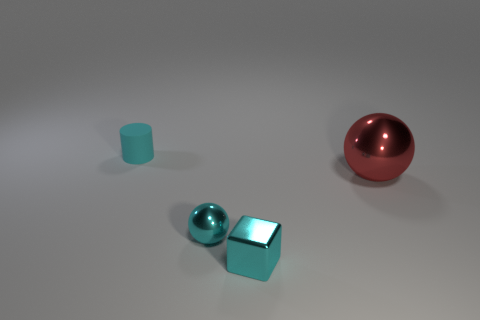What number of other objects are there of the same color as the tiny matte cylinder?
Ensure brevity in your answer.  2. The tiny thing that is both on the left side of the small cube and to the right of the rubber cylinder is what color?
Your answer should be very brief. Cyan. There is a metallic sphere on the right side of the cyan metallic object to the right of the sphere to the left of the red sphere; what size is it?
Your answer should be very brief. Large. How many objects are balls on the right side of the metallic block or tiny cyan objects that are in front of the small cyan matte cylinder?
Provide a short and direct response. 3. There is a red metallic thing; what shape is it?
Give a very brief answer. Sphere. How many other things are made of the same material as the large thing?
Provide a short and direct response. 2. The cyan metallic object that is the same shape as the red shiny object is what size?
Ensure brevity in your answer.  Small. What is the material of the thing behind the shiny sphere behind the tiny cyan shiny sphere on the left side of the large thing?
Keep it short and to the point. Rubber. Are any small rubber cylinders visible?
Your answer should be very brief. Yes. There is a small sphere; is its color the same as the small thing to the left of the cyan ball?
Make the answer very short. Yes. 